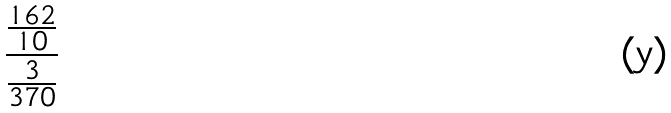Convert formula to latex. <formula><loc_0><loc_0><loc_500><loc_500>\frac { \frac { 1 6 2 } { 1 0 } } { \frac { 3 } { 3 7 0 } }</formula> 